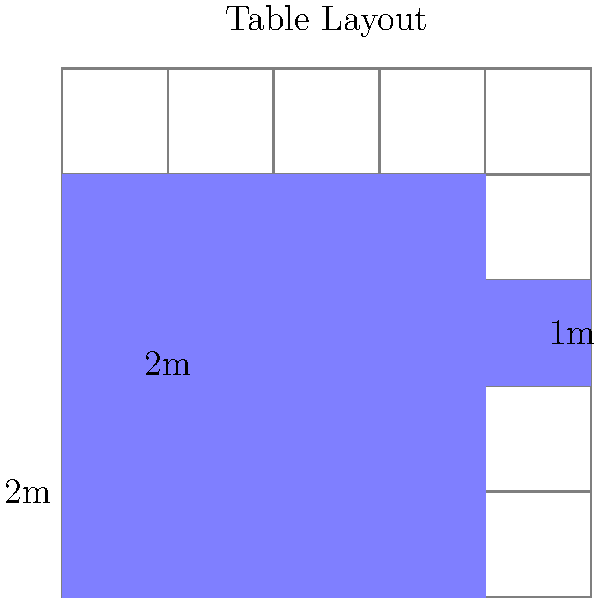You're planning to arrange square tables in your bar to maximize seating capacity. The layout is shown in the diagram above, where each square represents a table. If each large square table has a side length of 2 meters and the small square table has a side length of 1 meter, what is the total area occupied by all the tables? Let's break this down step-by-step:

1) First, let's count the number of tables:
   - There are 4 large square tables (2m x 2m each)
   - There is 1 small square table (1m x 1m)

2) Calculate the area of one large table:
   Area = side length² = 2m × 2m = 4m²

3) Calculate the total area of all large tables:
   Total large table area = 4 × 4m² = 16m²

4) Calculate the area of the small table:
   Area = side length² = 1m × 1m = 1m²

5) Sum up the total area:
   Total area = Area of large tables + Area of small table
               = 16m² + 1m² = 17m²

Therefore, the total area occupied by all the tables is 17 square meters.
Answer: 17m² 